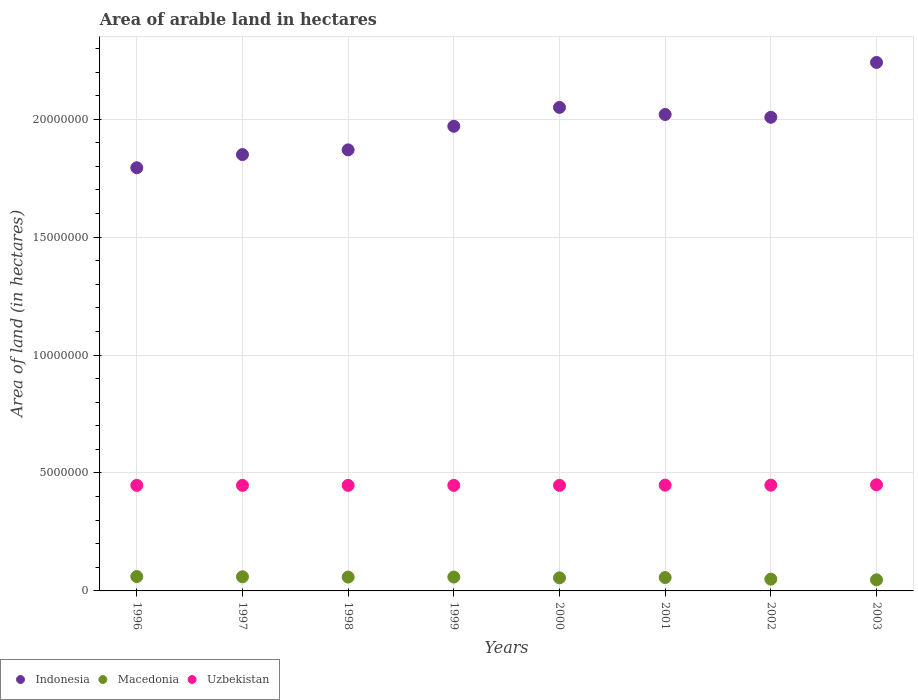How many different coloured dotlines are there?
Ensure brevity in your answer.  3. Is the number of dotlines equal to the number of legend labels?
Your answer should be very brief. Yes. What is the total arable land in Uzbekistan in 2003?
Your answer should be very brief. 4.50e+06. Across all years, what is the maximum total arable land in Indonesia?
Give a very brief answer. 2.24e+07. Across all years, what is the minimum total arable land in Indonesia?
Your answer should be compact. 1.79e+07. What is the total total arable land in Macedonia in the graph?
Ensure brevity in your answer.  4.48e+06. What is the difference between the total arable land in Indonesia in 1999 and that in 2002?
Keep it short and to the point. -3.81e+05. What is the difference between the total arable land in Indonesia in 1999 and the total arable land in Uzbekistan in 2001?
Your answer should be compact. 1.52e+07. What is the average total arable land in Uzbekistan per year?
Ensure brevity in your answer.  4.48e+06. In the year 2002, what is the difference between the total arable land in Macedonia and total arable land in Uzbekistan?
Keep it short and to the point. -3.98e+06. In how many years, is the total arable land in Uzbekistan greater than 13000000 hectares?
Ensure brevity in your answer.  0. What is the ratio of the total arable land in Macedonia in 1996 to that in 1999?
Offer a very short reply. 1.04. Is the difference between the total arable land in Macedonia in 2000 and 2001 greater than the difference between the total arable land in Uzbekistan in 2000 and 2001?
Give a very brief answer. No. What is the difference between the highest and the second highest total arable land in Macedonia?
Your answer should be very brief. 9000. What is the difference between the highest and the lowest total arable land in Macedonia?
Provide a succinct answer. 1.38e+05. In how many years, is the total arable land in Macedonia greater than the average total arable land in Macedonia taken over all years?
Make the answer very short. 5. Is the sum of the total arable land in Macedonia in 1999 and 2003 greater than the maximum total arable land in Indonesia across all years?
Offer a terse response. No. How many dotlines are there?
Ensure brevity in your answer.  3. Are the values on the major ticks of Y-axis written in scientific E-notation?
Offer a terse response. No. Where does the legend appear in the graph?
Give a very brief answer. Bottom left. How many legend labels are there?
Make the answer very short. 3. What is the title of the graph?
Give a very brief answer. Area of arable land in hectares. Does "Marshall Islands" appear as one of the legend labels in the graph?
Give a very brief answer. No. What is the label or title of the Y-axis?
Offer a very short reply. Area of land (in hectares). What is the Area of land (in hectares) of Indonesia in 1996?
Offer a terse response. 1.79e+07. What is the Area of land (in hectares) of Macedonia in 1996?
Your answer should be compact. 6.09e+05. What is the Area of land (in hectares) of Uzbekistan in 1996?
Give a very brief answer. 4.48e+06. What is the Area of land (in hectares) in Indonesia in 1997?
Your answer should be compact. 1.85e+07. What is the Area of land (in hectares) in Uzbekistan in 1997?
Your answer should be very brief. 4.48e+06. What is the Area of land (in hectares) in Indonesia in 1998?
Your response must be concise. 1.87e+07. What is the Area of land (in hectares) of Macedonia in 1998?
Make the answer very short. 5.87e+05. What is the Area of land (in hectares) of Uzbekistan in 1998?
Provide a succinct answer. 4.48e+06. What is the Area of land (in hectares) in Indonesia in 1999?
Ensure brevity in your answer.  1.97e+07. What is the Area of land (in hectares) of Macedonia in 1999?
Your response must be concise. 5.88e+05. What is the Area of land (in hectares) in Uzbekistan in 1999?
Offer a terse response. 4.48e+06. What is the Area of land (in hectares) of Indonesia in 2000?
Make the answer very short. 2.05e+07. What is the Area of land (in hectares) in Macedonia in 2000?
Provide a short and direct response. 5.55e+05. What is the Area of land (in hectares) in Uzbekistan in 2000?
Provide a short and direct response. 4.48e+06. What is the Area of land (in hectares) of Indonesia in 2001?
Offer a terse response. 2.02e+07. What is the Area of land (in hectares) of Macedonia in 2001?
Make the answer very short. 5.68e+05. What is the Area of land (in hectares) in Uzbekistan in 2001?
Offer a terse response. 4.48e+06. What is the Area of land (in hectares) in Indonesia in 2002?
Your response must be concise. 2.01e+07. What is the Area of land (in hectares) of Macedonia in 2002?
Make the answer very short. 4.99e+05. What is the Area of land (in hectares) of Uzbekistan in 2002?
Your answer should be compact. 4.48e+06. What is the Area of land (in hectares) in Indonesia in 2003?
Keep it short and to the point. 2.24e+07. What is the Area of land (in hectares) of Macedonia in 2003?
Provide a succinct answer. 4.71e+05. What is the Area of land (in hectares) of Uzbekistan in 2003?
Provide a short and direct response. 4.50e+06. Across all years, what is the maximum Area of land (in hectares) in Indonesia?
Provide a succinct answer. 2.24e+07. Across all years, what is the maximum Area of land (in hectares) of Macedonia?
Offer a terse response. 6.09e+05. Across all years, what is the maximum Area of land (in hectares) of Uzbekistan?
Make the answer very short. 4.50e+06. Across all years, what is the minimum Area of land (in hectares) of Indonesia?
Your response must be concise. 1.79e+07. Across all years, what is the minimum Area of land (in hectares) in Macedonia?
Make the answer very short. 4.71e+05. Across all years, what is the minimum Area of land (in hectares) in Uzbekistan?
Keep it short and to the point. 4.48e+06. What is the total Area of land (in hectares) in Indonesia in the graph?
Your answer should be very brief. 1.58e+08. What is the total Area of land (in hectares) in Macedonia in the graph?
Your response must be concise. 4.48e+06. What is the total Area of land (in hectares) in Uzbekistan in the graph?
Offer a very short reply. 3.58e+07. What is the difference between the Area of land (in hectares) of Indonesia in 1996 and that in 1997?
Give a very brief answer. -5.59e+05. What is the difference between the Area of land (in hectares) of Macedonia in 1996 and that in 1997?
Ensure brevity in your answer.  9000. What is the difference between the Area of land (in hectares) in Indonesia in 1996 and that in 1998?
Ensure brevity in your answer.  -7.59e+05. What is the difference between the Area of land (in hectares) in Macedonia in 1996 and that in 1998?
Ensure brevity in your answer.  2.20e+04. What is the difference between the Area of land (in hectares) in Uzbekistan in 1996 and that in 1998?
Give a very brief answer. 0. What is the difference between the Area of land (in hectares) in Indonesia in 1996 and that in 1999?
Ensure brevity in your answer.  -1.76e+06. What is the difference between the Area of land (in hectares) in Macedonia in 1996 and that in 1999?
Your answer should be compact. 2.10e+04. What is the difference between the Area of land (in hectares) in Uzbekistan in 1996 and that in 1999?
Give a very brief answer. 0. What is the difference between the Area of land (in hectares) of Indonesia in 1996 and that in 2000?
Offer a terse response. -2.56e+06. What is the difference between the Area of land (in hectares) of Macedonia in 1996 and that in 2000?
Provide a succinct answer. 5.40e+04. What is the difference between the Area of land (in hectares) of Indonesia in 1996 and that in 2001?
Provide a short and direct response. -2.26e+06. What is the difference between the Area of land (in hectares) in Macedonia in 1996 and that in 2001?
Your response must be concise. 4.10e+04. What is the difference between the Area of land (in hectares) of Indonesia in 1996 and that in 2002?
Make the answer very short. -2.14e+06. What is the difference between the Area of land (in hectares) of Macedonia in 1996 and that in 2002?
Offer a very short reply. 1.10e+05. What is the difference between the Area of land (in hectares) in Uzbekistan in 1996 and that in 2002?
Provide a short and direct response. -9000. What is the difference between the Area of land (in hectares) of Indonesia in 1996 and that in 2003?
Provide a short and direct response. -4.46e+06. What is the difference between the Area of land (in hectares) of Macedonia in 1996 and that in 2003?
Provide a short and direct response. 1.38e+05. What is the difference between the Area of land (in hectares) of Uzbekistan in 1996 and that in 2003?
Your response must be concise. -2.50e+04. What is the difference between the Area of land (in hectares) in Indonesia in 1997 and that in 1998?
Make the answer very short. -2.00e+05. What is the difference between the Area of land (in hectares) in Macedonia in 1997 and that in 1998?
Offer a very short reply. 1.30e+04. What is the difference between the Area of land (in hectares) in Indonesia in 1997 and that in 1999?
Offer a very short reply. -1.20e+06. What is the difference between the Area of land (in hectares) in Macedonia in 1997 and that in 1999?
Your response must be concise. 1.20e+04. What is the difference between the Area of land (in hectares) in Uzbekistan in 1997 and that in 1999?
Your answer should be very brief. 0. What is the difference between the Area of land (in hectares) of Macedonia in 1997 and that in 2000?
Ensure brevity in your answer.  4.50e+04. What is the difference between the Area of land (in hectares) of Indonesia in 1997 and that in 2001?
Keep it short and to the point. -1.70e+06. What is the difference between the Area of land (in hectares) in Macedonia in 1997 and that in 2001?
Your answer should be very brief. 3.20e+04. What is the difference between the Area of land (in hectares) of Indonesia in 1997 and that in 2002?
Provide a succinct answer. -1.58e+06. What is the difference between the Area of land (in hectares) in Macedonia in 1997 and that in 2002?
Ensure brevity in your answer.  1.01e+05. What is the difference between the Area of land (in hectares) of Uzbekistan in 1997 and that in 2002?
Provide a succinct answer. -9000. What is the difference between the Area of land (in hectares) in Indonesia in 1997 and that in 2003?
Give a very brief answer. -3.91e+06. What is the difference between the Area of land (in hectares) in Macedonia in 1997 and that in 2003?
Provide a succinct answer. 1.29e+05. What is the difference between the Area of land (in hectares) in Uzbekistan in 1997 and that in 2003?
Give a very brief answer. -2.50e+04. What is the difference between the Area of land (in hectares) of Macedonia in 1998 and that in 1999?
Provide a succinct answer. -1000. What is the difference between the Area of land (in hectares) in Indonesia in 1998 and that in 2000?
Your answer should be very brief. -1.80e+06. What is the difference between the Area of land (in hectares) of Macedonia in 1998 and that in 2000?
Offer a terse response. 3.20e+04. What is the difference between the Area of land (in hectares) of Uzbekistan in 1998 and that in 2000?
Keep it short and to the point. 0. What is the difference between the Area of land (in hectares) in Indonesia in 1998 and that in 2001?
Your response must be concise. -1.50e+06. What is the difference between the Area of land (in hectares) of Macedonia in 1998 and that in 2001?
Offer a terse response. 1.90e+04. What is the difference between the Area of land (in hectares) of Uzbekistan in 1998 and that in 2001?
Make the answer very short. -10000. What is the difference between the Area of land (in hectares) in Indonesia in 1998 and that in 2002?
Offer a very short reply. -1.38e+06. What is the difference between the Area of land (in hectares) of Macedonia in 1998 and that in 2002?
Offer a terse response. 8.80e+04. What is the difference between the Area of land (in hectares) in Uzbekistan in 1998 and that in 2002?
Ensure brevity in your answer.  -9000. What is the difference between the Area of land (in hectares) in Indonesia in 1998 and that in 2003?
Your answer should be compact. -3.71e+06. What is the difference between the Area of land (in hectares) in Macedonia in 1998 and that in 2003?
Make the answer very short. 1.16e+05. What is the difference between the Area of land (in hectares) of Uzbekistan in 1998 and that in 2003?
Keep it short and to the point. -2.50e+04. What is the difference between the Area of land (in hectares) in Indonesia in 1999 and that in 2000?
Your answer should be compact. -8.00e+05. What is the difference between the Area of land (in hectares) of Macedonia in 1999 and that in 2000?
Offer a terse response. 3.30e+04. What is the difference between the Area of land (in hectares) in Indonesia in 1999 and that in 2001?
Offer a very short reply. -5.00e+05. What is the difference between the Area of land (in hectares) in Macedonia in 1999 and that in 2001?
Offer a very short reply. 2.00e+04. What is the difference between the Area of land (in hectares) in Uzbekistan in 1999 and that in 2001?
Offer a terse response. -10000. What is the difference between the Area of land (in hectares) of Indonesia in 1999 and that in 2002?
Keep it short and to the point. -3.81e+05. What is the difference between the Area of land (in hectares) in Macedonia in 1999 and that in 2002?
Provide a short and direct response. 8.90e+04. What is the difference between the Area of land (in hectares) in Uzbekistan in 1999 and that in 2002?
Make the answer very short. -9000. What is the difference between the Area of land (in hectares) of Indonesia in 1999 and that in 2003?
Provide a succinct answer. -2.71e+06. What is the difference between the Area of land (in hectares) of Macedonia in 1999 and that in 2003?
Give a very brief answer. 1.17e+05. What is the difference between the Area of land (in hectares) of Uzbekistan in 1999 and that in 2003?
Provide a succinct answer. -2.50e+04. What is the difference between the Area of land (in hectares) in Indonesia in 2000 and that in 2001?
Your response must be concise. 3.00e+05. What is the difference between the Area of land (in hectares) in Macedonia in 2000 and that in 2001?
Your answer should be very brief. -1.30e+04. What is the difference between the Area of land (in hectares) in Uzbekistan in 2000 and that in 2001?
Your answer should be very brief. -10000. What is the difference between the Area of land (in hectares) in Indonesia in 2000 and that in 2002?
Make the answer very short. 4.19e+05. What is the difference between the Area of land (in hectares) of Macedonia in 2000 and that in 2002?
Offer a terse response. 5.60e+04. What is the difference between the Area of land (in hectares) of Uzbekistan in 2000 and that in 2002?
Your answer should be very brief. -9000. What is the difference between the Area of land (in hectares) in Indonesia in 2000 and that in 2003?
Provide a succinct answer. -1.91e+06. What is the difference between the Area of land (in hectares) of Macedonia in 2000 and that in 2003?
Keep it short and to the point. 8.40e+04. What is the difference between the Area of land (in hectares) in Uzbekistan in 2000 and that in 2003?
Provide a succinct answer. -2.50e+04. What is the difference between the Area of land (in hectares) in Indonesia in 2001 and that in 2002?
Your answer should be compact. 1.19e+05. What is the difference between the Area of land (in hectares) of Macedonia in 2001 and that in 2002?
Ensure brevity in your answer.  6.90e+04. What is the difference between the Area of land (in hectares) in Uzbekistan in 2001 and that in 2002?
Keep it short and to the point. 1000. What is the difference between the Area of land (in hectares) in Indonesia in 2001 and that in 2003?
Give a very brief answer. -2.21e+06. What is the difference between the Area of land (in hectares) of Macedonia in 2001 and that in 2003?
Your answer should be very brief. 9.70e+04. What is the difference between the Area of land (in hectares) of Uzbekistan in 2001 and that in 2003?
Your answer should be very brief. -1.50e+04. What is the difference between the Area of land (in hectares) of Indonesia in 2002 and that in 2003?
Make the answer very short. -2.32e+06. What is the difference between the Area of land (in hectares) of Macedonia in 2002 and that in 2003?
Keep it short and to the point. 2.80e+04. What is the difference between the Area of land (in hectares) of Uzbekistan in 2002 and that in 2003?
Give a very brief answer. -1.60e+04. What is the difference between the Area of land (in hectares) of Indonesia in 1996 and the Area of land (in hectares) of Macedonia in 1997?
Make the answer very short. 1.73e+07. What is the difference between the Area of land (in hectares) in Indonesia in 1996 and the Area of land (in hectares) in Uzbekistan in 1997?
Provide a succinct answer. 1.35e+07. What is the difference between the Area of land (in hectares) in Macedonia in 1996 and the Area of land (in hectares) in Uzbekistan in 1997?
Make the answer very short. -3.87e+06. What is the difference between the Area of land (in hectares) in Indonesia in 1996 and the Area of land (in hectares) in Macedonia in 1998?
Your answer should be compact. 1.74e+07. What is the difference between the Area of land (in hectares) in Indonesia in 1996 and the Area of land (in hectares) in Uzbekistan in 1998?
Offer a terse response. 1.35e+07. What is the difference between the Area of land (in hectares) in Macedonia in 1996 and the Area of land (in hectares) in Uzbekistan in 1998?
Your answer should be very brief. -3.87e+06. What is the difference between the Area of land (in hectares) of Indonesia in 1996 and the Area of land (in hectares) of Macedonia in 1999?
Keep it short and to the point. 1.74e+07. What is the difference between the Area of land (in hectares) of Indonesia in 1996 and the Area of land (in hectares) of Uzbekistan in 1999?
Give a very brief answer. 1.35e+07. What is the difference between the Area of land (in hectares) of Macedonia in 1996 and the Area of land (in hectares) of Uzbekistan in 1999?
Make the answer very short. -3.87e+06. What is the difference between the Area of land (in hectares) in Indonesia in 1996 and the Area of land (in hectares) in Macedonia in 2000?
Offer a terse response. 1.74e+07. What is the difference between the Area of land (in hectares) of Indonesia in 1996 and the Area of land (in hectares) of Uzbekistan in 2000?
Provide a succinct answer. 1.35e+07. What is the difference between the Area of land (in hectares) in Macedonia in 1996 and the Area of land (in hectares) in Uzbekistan in 2000?
Keep it short and to the point. -3.87e+06. What is the difference between the Area of land (in hectares) of Indonesia in 1996 and the Area of land (in hectares) of Macedonia in 2001?
Give a very brief answer. 1.74e+07. What is the difference between the Area of land (in hectares) of Indonesia in 1996 and the Area of land (in hectares) of Uzbekistan in 2001?
Your answer should be compact. 1.35e+07. What is the difference between the Area of land (in hectares) of Macedonia in 1996 and the Area of land (in hectares) of Uzbekistan in 2001?
Offer a very short reply. -3.88e+06. What is the difference between the Area of land (in hectares) of Indonesia in 1996 and the Area of land (in hectares) of Macedonia in 2002?
Offer a terse response. 1.74e+07. What is the difference between the Area of land (in hectares) of Indonesia in 1996 and the Area of land (in hectares) of Uzbekistan in 2002?
Your answer should be compact. 1.35e+07. What is the difference between the Area of land (in hectares) in Macedonia in 1996 and the Area of land (in hectares) in Uzbekistan in 2002?
Provide a short and direct response. -3.88e+06. What is the difference between the Area of land (in hectares) of Indonesia in 1996 and the Area of land (in hectares) of Macedonia in 2003?
Keep it short and to the point. 1.75e+07. What is the difference between the Area of land (in hectares) in Indonesia in 1996 and the Area of land (in hectares) in Uzbekistan in 2003?
Keep it short and to the point. 1.34e+07. What is the difference between the Area of land (in hectares) of Macedonia in 1996 and the Area of land (in hectares) of Uzbekistan in 2003?
Your answer should be very brief. -3.89e+06. What is the difference between the Area of land (in hectares) in Indonesia in 1997 and the Area of land (in hectares) in Macedonia in 1998?
Offer a very short reply. 1.79e+07. What is the difference between the Area of land (in hectares) of Indonesia in 1997 and the Area of land (in hectares) of Uzbekistan in 1998?
Offer a very short reply. 1.40e+07. What is the difference between the Area of land (in hectares) of Macedonia in 1997 and the Area of land (in hectares) of Uzbekistan in 1998?
Make the answer very short. -3.88e+06. What is the difference between the Area of land (in hectares) of Indonesia in 1997 and the Area of land (in hectares) of Macedonia in 1999?
Your response must be concise. 1.79e+07. What is the difference between the Area of land (in hectares) in Indonesia in 1997 and the Area of land (in hectares) in Uzbekistan in 1999?
Provide a short and direct response. 1.40e+07. What is the difference between the Area of land (in hectares) in Macedonia in 1997 and the Area of land (in hectares) in Uzbekistan in 1999?
Make the answer very short. -3.88e+06. What is the difference between the Area of land (in hectares) in Indonesia in 1997 and the Area of land (in hectares) in Macedonia in 2000?
Offer a very short reply. 1.79e+07. What is the difference between the Area of land (in hectares) in Indonesia in 1997 and the Area of land (in hectares) in Uzbekistan in 2000?
Offer a terse response. 1.40e+07. What is the difference between the Area of land (in hectares) of Macedonia in 1997 and the Area of land (in hectares) of Uzbekistan in 2000?
Keep it short and to the point. -3.88e+06. What is the difference between the Area of land (in hectares) in Indonesia in 1997 and the Area of land (in hectares) in Macedonia in 2001?
Offer a terse response. 1.79e+07. What is the difference between the Area of land (in hectares) of Indonesia in 1997 and the Area of land (in hectares) of Uzbekistan in 2001?
Provide a short and direct response. 1.40e+07. What is the difference between the Area of land (in hectares) in Macedonia in 1997 and the Area of land (in hectares) in Uzbekistan in 2001?
Make the answer very short. -3.88e+06. What is the difference between the Area of land (in hectares) of Indonesia in 1997 and the Area of land (in hectares) of Macedonia in 2002?
Provide a succinct answer. 1.80e+07. What is the difference between the Area of land (in hectares) in Indonesia in 1997 and the Area of land (in hectares) in Uzbekistan in 2002?
Make the answer very short. 1.40e+07. What is the difference between the Area of land (in hectares) of Macedonia in 1997 and the Area of land (in hectares) of Uzbekistan in 2002?
Your answer should be very brief. -3.88e+06. What is the difference between the Area of land (in hectares) in Indonesia in 1997 and the Area of land (in hectares) in Macedonia in 2003?
Offer a very short reply. 1.80e+07. What is the difference between the Area of land (in hectares) in Indonesia in 1997 and the Area of land (in hectares) in Uzbekistan in 2003?
Offer a very short reply. 1.40e+07. What is the difference between the Area of land (in hectares) in Macedonia in 1997 and the Area of land (in hectares) in Uzbekistan in 2003?
Your response must be concise. -3.90e+06. What is the difference between the Area of land (in hectares) in Indonesia in 1998 and the Area of land (in hectares) in Macedonia in 1999?
Make the answer very short. 1.81e+07. What is the difference between the Area of land (in hectares) of Indonesia in 1998 and the Area of land (in hectares) of Uzbekistan in 1999?
Offer a very short reply. 1.42e+07. What is the difference between the Area of land (in hectares) of Macedonia in 1998 and the Area of land (in hectares) of Uzbekistan in 1999?
Provide a succinct answer. -3.89e+06. What is the difference between the Area of land (in hectares) of Indonesia in 1998 and the Area of land (in hectares) of Macedonia in 2000?
Your response must be concise. 1.81e+07. What is the difference between the Area of land (in hectares) of Indonesia in 1998 and the Area of land (in hectares) of Uzbekistan in 2000?
Your response must be concise. 1.42e+07. What is the difference between the Area of land (in hectares) in Macedonia in 1998 and the Area of land (in hectares) in Uzbekistan in 2000?
Make the answer very short. -3.89e+06. What is the difference between the Area of land (in hectares) in Indonesia in 1998 and the Area of land (in hectares) in Macedonia in 2001?
Your answer should be very brief. 1.81e+07. What is the difference between the Area of land (in hectares) in Indonesia in 1998 and the Area of land (in hectares) in Uzbekistan in 2001?
Offer a terse response. 1.42e+07. What is the difference between the Area of land (in hectares) in Macedonia in 1998 and the Area of land (in hectares) in Uzbekistan in 2001?
Your response must be concise. -3.90e+06. What is the difference between the Area of land (in hectares) of Indonesia in 1998 and the Area of land (in hectares) of Macedonia in 2002?
Offer a terse response. 1.82e+07. What is the difference between the Area of land (in hectares) in Indonesia in 1998 and the Area of land (in hectares) in Uzbekistan in 2002?
Your response must be concise. 1.42e+07. What is the difference between the Area of land (in hectares) of Macedonia in 1998 and the Area of land (in hectares) of Uzbekistan in 2002?
Ensure brevity in your answer.  -3.90e+06. What is the difference between the Area of land (in hectares) in Indonesia in 1998 and the Area of land (in hectares) in Macedonia in 2003?
Your answer should be very brief. 1.82e+07. What is the difference between the Area of land (in hectares) in Indonesia in 1998 and the Area of land (in hectares) in Uzbekistan in 2003?
Keep it short and to the point. 1.42e+07. What is the difference between the Area of land (in hectares) of Macedonia in 1998 and the Area of land (in hectares) of Uzbekistan in 2003?
Make the answer very short. -3.91e+06. What is the difference between the Area of land (in hectares) in Indonesia in 1999 and the Area of land (in hectares) in Macedonia in 2000?
Provide a succinct answer. 1.91e+07. What is the difference between the Area of land (in hectares) of Indonesia in 1999 and the Area of land (in hectares) of Uzbekistan in 2000?
Offer a very short reply. 1.52e+07. What is the difference between the Area of land (in hectares) of Macedonia in 1999 and the Area of land (in hectares) of Uzbekistan in 2000?
Offer a very short reply. -3.89e+06. What is the difference between the Area of land (in hectares) in Indonesia in 1999 and the Area of land (in hectares) in Macedonia in 2001?
Your answer should be very brief. 1.91e+07. What is the difference between the Area of land (in hectares) in Indonesia in 1999 and the Area of land (in hectares) in Uzbekistan in 2001?
Your response must be concise. 1.52e+07. What is the difference between the Area of land (in hectares) in Macedonia in 1999 and the Area of land (in hectares) in Uzbekistan in 2001?
Ensure brevity in your answer.  -3.90e+06. What is the difference between the Area of land (in hectares) in Indonesia in 1999 and the Area of land (in hectares) in Macedonia in 2002?
Give a very brief answer. 1.92e+07. What is the difference between the Area of land (in hectares) in Indonesia in 1999 and the Area of land (in hectares) in Uzbekistan in 2002?
Offer a very short reply. 1.52e+07. What is the difference between the Area of land (in hectares) of Macedonia in 1999 and the Area of land (in hectares) of Uzbekistan in 2002?
Your response must be concise. -3.90e+06. What is the difference between the Area of land (in hectares) in Indonesia in 1999 and the Area of land (in hectares) in Macedonia in 2003?
Give a very brief answer. 1.92e+07. What is the difference between the Area of land (in hectares) in Indonesia in 1999 and the Area of land (in hectares) in Uzbekistan in 2003?
Your answer should be very brief. 1.52e+07. What is the difference between the Area of land (in hectares) of Macedonia in 1999 and the Area of land (in hectares) of Uzbekistan in 2003?
Offer a very short reply. -3.91e+06. What is the difference between the Area of land (in hectares) of Indonesia in 2000 and the Area of land (in hectares) of Macedonia in 2001?
Make the answer very short. 1.99e+07. What is the difference between the Area of land (in hectares) in Indonesia in 2000 and the Area of land (in hectares) in Uzbekistan in 2001?
Provide a succinct answer. 1.60e+07. What is the difference between the Area of land (in hectares) in Macedonia in 2000 and the Area of land (in hectares) in Uzbekistan in 2001?
Your response must be concise. -3.93e+06. What is the difference between the Area of land (in hectares) of Indonesia in 2000 and the Area of land (in hectares) of Macedonia in 2002?
Give a very brief answer. 2.00e+07. What is the difference between the Area of land (in hectares) of Indonesia in 2000 and the Area of land (in hectares) of Uzbekistan in 2002?
Keep it short and to the point. 1.60e+07. What is the difference between the Area of land (in hectares) in Macedonia in 2000 and the Area of land (in hectares) in Uzbekistan in 2002?
Your answer should be very brief. -3.93e+06. What is the difference between the Area of land (in hectares) in Indonesia in 2000 and the Area of land (in hectares) in Macedonia in 2003?
Provide a short and direct response. 2.00e+07. What is the difference between the Area of land (in hectares) in Indonesia in 2000 and the Area of land (in hectares) in Uzbekistan in 2003?
Keep it short and to the point. 1.60e+07. What is the difference between the Area of land (in hectares) in Macedonia in 2000 and the Area of land (in hectares) in Uzbekistan in 2003?
Give a very brief answer. -3.94e+06. What is the difference between the Area of land (in hectares) of Indonesia in 2001 and the Area of land (in hectares) of Macedonia in 2002?
Offer a terse response. 1.97e+07. What is the difference between the Area of land (in hectares) of Indonesia in 2001 and the Area of land (in hectares) of Uzbekistan in 2002?
Make the answer very short. 1.57e+07. What is the difference between the Area of land (in hectares) in Macedonia in 2001 and the Area of land (in hectares) in Uzbekistan in 2002?
Provide a succinct answer. -3.92e+06. What is the difference between the Area of land (in hectares) in Indonesia in 2001 and the Area of land (in hectares) in Macedonia in 2003?
Offer a terse response. 1.97e+07. What is the difference between the Area of land (in hectares) of Indonesia in 2001 and the Area of land (in hectares) of Uzbekistan in 2003?
Make the answer very short. 1.57e+07. What is the difference between the Area of land (in hectares) of Macedonia in 2001 and the Area of land (in hectares) of Uzbekistan in 2003?
Keep it short and to the point. -3.93e+06. What is the difference between the Area of land (in hectares) of Indonesia in 2002 and the Area of land (in hectares) of Macedonia in 2003?
Your response must be concise. 1.96e+07. What is the difference between the Area of land (in hectares) in Indonesia in 2002 and the Area of land (in hectares) in Uzbekistan in 2003?
Your answer should be very brief. 1.56e+07. What is the difference between the Area of land (in hectares) of Macedonia in 2002 and the Area of land (in hectares) of Uzbekistan in 2003?
Provide a succinct answer. -4.00e+06. What is the average Area of land (in hectares) of Indonesia per year?
Make the answer very short. 1.98e+07. What is the average Area of land (in hectares) in Macedonia per year?
Offer a very short reply. 5.60e+05. What is the average Area of land (in hectares) in Uzbekistan per year?
Offer a very short reply. 4.48e+06. In the year 1996, what is the difference between the Area of land (in hectares) in Indonesia and Area of land (in hectares) in Macedonia?
Offer a terse response. 1.73e+07. In the year 1996, what is the difference between the Area of land (in hectares) in Indonesia and Area of land (in hectares) in Uzbekistan?
Your answer should be compact. 1.35e+07. In the year 1996, what is the difference between the Area of land (in hectares) in Macedonia and Area of land (in hectares) in Uzbekistan?
Your answer should be compact. -3.87e+06. In the year 1997, what is the difference between the Area of land (in hectares) in Indonesia and Area of land (in hectares) in Macedonia?
Provide a short and direct response. 1.79e+07. In the year 1997, what is the difference between the Area of land (in hectares) in Indonesia and Area of land (in hectares) in Uzbekistan?
Your response must be concise. 1.40e+07. In the year 1997, what is the difference between the Area of land (in hectares) of Macedonia and Area of land (in hectares) of Uzbekistan?
Offer a terse response. -3.88e+06. In the year 1998, what is the difference between the Area of land (in hectares) in Indonesia and Area of land (in hectares) in Macedonia?
Your answer should be very brief. 1.81e+07. In the year 1998, what is the difference between the Area of land (in hectares) in Indonesia and Area of land (in hectares) in Uzbekistan?
Offer a terse response. 1.42e+07. In the year 1998, what is the difference between the Area of land (in hectares) in Macedonia and Area of land (in hectares) in Uzbekistan?
Ensure brevity in your answer.  -3.89e+06. In the year 1999, what is the difference between the Area of land (in hectares) in Indonesia and Area of land (in hectares) in Macedonia?
Your answer should be very brief. 1.91e+07. In the year 1999, what is the difference between the Area of land (in hectares) in Indonesia and Area of land (in hectares) in Uzbekistan?
Provide a short and direct response. 1.52e+07. In the year 1999, what is the difference between the Area of land (in hectares) in Macedonia and Area of land (in hectares) in Uzbekistan?
Offer a very short reply. -3.89e+06. In the year 2000, what is the difference between the Area of land (in hectares) of Indonesia and Area of land (in hectares) of Macedonia?
Ensure brevity in your answer.  1.99e+07. In the year 2000, what is the difference between the Area of land (in hectares) in Indonesia and Area of land (in hectares) in Uzbekistan?
Ensure brevity in your answer.  1.60e+07. In the year 2000, what is the difference between the Area of land (in hectares) in Macedonia and Area of land (in hectares) in Uzbekistan?
Ensure brevity in your answer.  -3.92e+06. In the year 2001, what is the difference between the Area of land (in hectares) in Indonesia and Area of land (in hectares) in Macedonia?
Keep it short and to the point. 1.96e+07. In the year 2001, what is the difference between the Area of land (in hectares) of Indonesia and Area of land (in hectares) of Uzbekistan?
Your answer should be very brief. 1.57e+07. In the year 2001, what is the difference between the Area of land (in hectares) of Macedonia and Area of land (in hectares) of Uzbekistan?
Your answer should be very brief. -3.92e+06. In the year 2002, what is the difference between the Area of land (in hectares) in Indonesia and Area of land (in hectares) in Macedonia?
Offer a terse response. 1.96e+07. In the year 2002, what is the difference between the Area of land (in hectares) of Indonesia and Area of land (in hectares) of Uzbekistan?
Make the answer very short. 1.56e+07. In the year 2002, what is the difference between the Area of land (in hectares) in Macedonia and Area of land (in hectares) in Uzbekistan?
Keep it short and to the point. -3.98e+06. In the year 2003, what is the difference between the Area of land (in hectares) in Indonesia and Area of land (in hectares) in Macedonia?
Give a very brief answer. 2.19e+07. In the year 2003, what is the difference between the Area of land (in hectares) of Indonesia and Area of land (in hectares) of Uzbekistan?
Ensure brevity in your answer.  1.79e+07. In the year 2003, what is the difference between the Area of land (in hectares) of Macedonia and Area of land (in hectares) of Uzbekistan?
Your answer should be compact. -4.03e+06. What is the ratio of the Area of land (in hectares) in Indonesia in 1996 to that in 1997?
Offer a very short reply. 0.97. What is the ratio of the Area of land (in hectares) in Indonesia in 1996 to that in 1998?
Offer a terse response. 0.96. What is the ratio of the Area of land (in hectares) in Macedonia in 1996 to that in 1998?
Provide a succinct answer. 1.04. What is the ratio of the Area of land (in hectares) in Indonesia in 1996 to that in 1999?
Your answer should be very brief. 0.91. What is the ratio of the Area of land (in hectares) of Macedonia in 1996 to that in 1999?
Ensure brevity in your answer.  1.04. What is the ratio of the Area of land (in hectares) of Indonesia in 1996 to that in 2000?
Provide a succinct answer. 0.88. What is the ratio of the Area of land (in hectares) in Macedonia in 1996 to that in 2000?
Make the answer very short. 1.1. What is the ratio of the Area of land (in hectares) in Indonesia in 1996 to that in 2001?
Offer a terse response. 0.89. What is the ratio of the Area of land (in hectares) of Macedonia in 1996 to that in 2001?
Ensure brevity in your answer.  1.07. What is the ratio of the Area of land (in hectares) in Indonesia in 1996 to that in 2002?
Give a very brief answer. 0.89. What is the ratio of the Area of land (in hectares) in Macedonia in 1996 to that in 2002?
Ensure brevity in your answer.  1.22. What is the ratio of the Area of land (in hectares) in Uzbekistan in 1996 to that in 2002?
Your answer should be compact. 1. What is the ratio of the Area of land (in hectares) of Indonesia in 1996 to that in 2003?
Offer a terse response. 0.8. What is the ratio of the Area of land (in hectares) of Macedonia in 1996 to that in 2003?
Provide a succinct answer. 1.29. What is the ratio of the Area of land (in hectares) in Indonesia in 1997 to that in 1998?
Your response must be concise. 0.99. What is the ratio of the Area of land (in hectares) in Macedonia in 1997 to that in 1998?
Offer a terse response. 1.02. What is the ratio of the Area of land (in hectares) in Indonesia in 1997 to that in 1999?
Give a very brief answer. 0.94. What is the ratio of the Area of land (in hectares) in Macedonia in 1997 to that in 1999?
Offer a very short reply. 1.02. What is the ratio of the Area of land (in hectares) of Uzbekistan in 1997 to that in 1999?
Provide a short and direct response. 1. What is the ratio of the Area of land (in hectares) of Indonesia in 1997 to that in 2000?
Make the answer very short. 0.9. What is the ratio of the Area of land (in hectares) of Macedonia in 1997 to that in 2000?
Give a very brief answer. 1.08. What is the ratio of the Area of land (in hectares) of Uzbekistan in 1997 to that in 2000?
Your answer should be compact. 1. What is the ratio of the Area of land (in hectares) in Indonesia in 1997 to that in 2001?
Offer a terse response. 0.92. What is the ratio of the Area of land (in hectares) of Macedonia in 1997 to that in 2001?
Your answer should be very brief. 1.06. What is the ratio of the Area of land (in hectares) in Uzbekistan in 1997 to that in 2001?
Keep it short and to the point. 1. What is the ratio of the Area of land (in hectares) of Indonesia in 1997 to that in 2002?
Ensure brevity in your answer.  0.92. What is the ratio of the Area of land (in hectares) of Macedonia in 1997 to that in 2002?
Your response must be concise. 1.2. What is the ratio of the Area of land (in hectares) of Indonesia in 1997 to that in 2003?
Your response must be concise. 0.83. What is the ratio of the Area of land (in hectares) of Macedonia in 1997 to that in 2003?
Make the answer very short. 1.27. What is the ratio of the Area of land (in hectares) in Indonesia in 1998 to that in 1999?
Ensure brevity in your answer.  0.95. What is the ratio of the Area of land (in hectares) in Macedonia in 1998 to that in 1999?
Make the answer very short. 1. What is the ratio of the Area of land (in hectares) in Indonesia in 1998 to that in 2000?
Keep it short and to the point. 0.91. What is the ratio of the Area of land (in hectares) in Macedonia in 1998 to that in 2000?
Your answer should be very brief. 1.06. What is the ratio of the Area of land (in hectares) of Uzbekistan in 1998 to that in 2000?
Your answer should be compact. 1. What is the ratio of the Area of land (in hectares) of Indonesia in 1998 to that in 2001?
Provide a short and direct response. 0.93. What is the ratio of the Area of land (in hectares) of Macedonia in 1998 to that in 2001?
Keep it short and to the point. 1.03. What is the ratio of the Area of land (in hectares) in Indonesia in 1998 to that in 2002?
Give a very brief answer. 0.93. What is the ratio of the Area of land (in hectares) in Macedonia in 1998 to that in 2002?
Your response must be concise. 1.18. What is the ratio of the Area of land (in hectares) of Indonesia in 1998 to that in 2003?
Provide a succinct answer. 0.83. What is the ratio of the Area of land (in hectares) of Macedonia in 1998 to that in 2003?
Give a very brief answer. 1.25. What is the ratio of the Area of land (in hectares) of Uzbekistan in 1998 to that in 2003?
Provide a short and direct response. 0.99. What is the ratio of the Area of land (in hectares) of Indonesia in 1999 to that in 2000?
Your response must be concise. 0.96. What is the ratio of the Area of land (in hectares) in Macedonia in 1999 to that in 2000?
Ensure brevity in your answer.  1.06. What is the ratio of the Area of land (in hectares) in Uzbekistan in 1999 to that in 2000?
Provide a short and direct response. 1. What is the ratio of the Area of land (in hectares) in Indonesia in 1999 to that in 2001?
Provide a succinct answer. 0.98. What is the ratio of the Area of land (in hectares) of Macedonia in 1999 to that in 2001?
Offer a terse response. 1.04. What is the ratio of the Area of land (in hectares) of Macedonia in 1999 to that in 2002?
Provide a succinct answer. 1.18. What is the ratio of the Area of land (in hectares) in Indonesia in 1999 to that in 2003?
Offer a very short reply. 0.88. What is the ratio of the Area of land (in hectares) of Macedonia in 1999 to that in 2003?
Make the answer very short. 1.25. What is the ratio of the Area of land (in hectares) of Indonesia in 2000 to that in 2001?
Provide a short and direct response. 1.01. What is the ratio of the Area of land (in hectares) in Macedonia in 2000 to that in 2001?
Give a very brief answer. 0.98. What is the ratio of the Area of land (in hectares) in Uzbekistan in 2000 to that in 2001?
Offer a terse response. 1. What is the ratio of the Area of land (in hectares) of Indonesia in 2000 to that in 2002?
Your response must be concise. 1.02. What is the ratio of the Area of land (in hectares) in Macedonia in 2000 to that in 2002?
Make the answer very short. 1.11. What is the ratio of the Area of land (in hectares) of Indonesia in 2000 to that in 2003?
Your answer should be compact. 0.91. What is the ratio of the Area of land (in hectares) of Macedonia in 2000 to that in 2003?
Ensure brevity in your answer.  1.18. What is the ratio of the Area of land (in hectares) in Uzbekistan in 2000 to that in 2003?
Provide a succinct answer. 0.99. What is the ratio of the Area of land (in hectares) of Indonesia in 2001 to that in 2002?
Offer a terse response. 1.01. What is the ratio of the Area of land (in hectares) of Macedonia in 2001 to that in 2002?
Provide a succinct answer. 1.14. What is the ratio of the Area of land (in hectares) of Indonesia in 2001 to that in 2003?
Your answer should be very brief. 0.9. What is the ratio of the Area of land (in hectares) of Macedonia in 2001 to that in 2003?
Offer a terse response. 1.21. What is the ratio of the Area of land (in hectares) of Indonesia in 2002 to that in 2003?
Keep it short and to the point. 0.9. What is the ratio of the Area of land (in hectares) of Macedonia in 2002 to that in 2003?
Provide a succinct answer. 1.06. What is the difference between the highest and the second highest Area of land (in hectares) in Indonesia?
Provide a succinct answer. 1.91e+06. What is the difference between the highest and the second highest Area of land (in hectares) in Macedonia?
Offer a very short reply. 9000. What is the difference between the highest and the second highest Area of land (in hectares) in Uzbekistan?
Offer a terse response. 1.50e+04. What is the difference between the highest and the lowest Area of land (in hectares) of Indonesia?
Your response must be concise. 4.46e+06. What is the difference between the highest and the lowest Area of land (in hectares) of Macedonia?
Offer a terse response. 1.38e+05. What is the difference between the highest and the lowest Area of land (in hectares) in Uzbekistan?
Your response must be concise. 2.50e+04. 